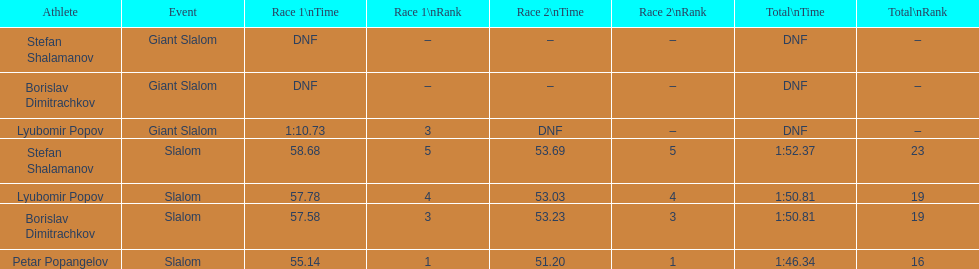Which athlete finished the first race but did not finish the second race? Lyubomir Popov. 